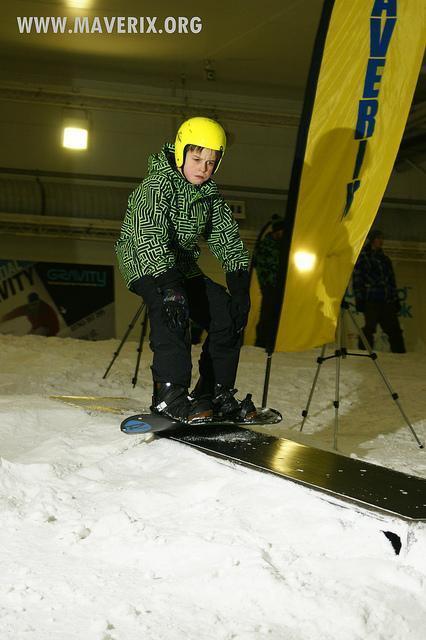How many people are there?
Give a very brief answer. 3. 